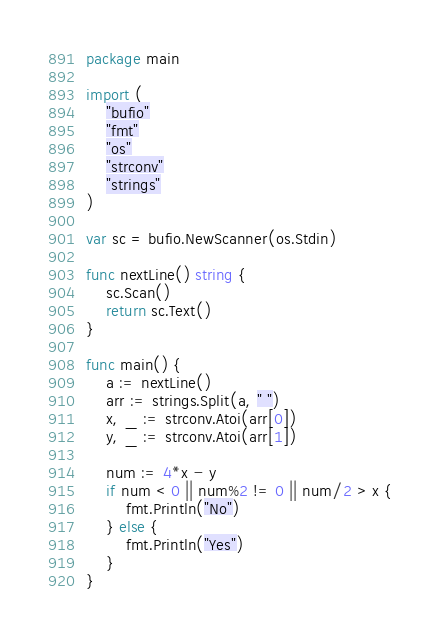<code> <loc_0><loc_0><loc_500><loc_500><_Go_>package main

import (
	"bufio"
	"fmt"
	"os"
	"strconv"
	"strings"
)

var sc = bufio.NewScanner(os.Stdin)

func nextLine() string {
	sc.Scan()
	return sc.Text()
}

func main() {
	a := nextLine()
	arr := strings.Split(a, " ")
	x, _ := strconv.Atoi(arr[0])
	y, _ := strconv.Atoi(arr[1])

	num := 4*x - y
	if num < 0 || num%2 != 0 || num/2 > x {
		fmt.Println("No")
	} else {
		fmt.Println("Yes")
	}
}
</code> 